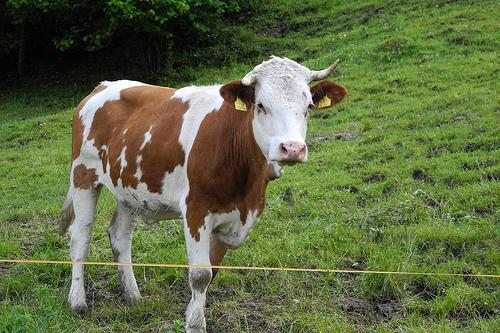What color is the tag on the cow's ear? Yellow. Analyze the cow's current action based on its positioning and surroundings. The cow is walking on grass with its feet visible and tail hanging down. Describe the surroundings of the cow. The cow is in a grassy area with green trees in the background and a shadow under a tree. What two colors make up the cow's fur? Brown and white. What type of vegetation are the cow and the tree growing from? Grassy hill and field. Tell me which part of the cow is pink. The cow's nose is pink. Enumerate the colors you can find in the grass. The grass is thick and green. Explain the image's quality according to the objects' details and level of clarity. The image has a high level of clarity and detail as the objects are clearly defined and contain specific coordinates and dimensions. Identify the object that's restricting the cow's movement. The yellow string or cord in front of the cow. How many legs does the cow have and what color are they? The cow has four legs and they are white. What is the color and shape of the cow's eyes and the state of its ears in the image? The cow has brown, dark eyes and brown, upright ears. Where does the tail of the cow appear to be hanging in the image? The tail of the cow is hanging down at the back. List the aspects of the cow's fur design that stand out in the image. The cow has brown and white fur patches, with some areas having tufts of white fur. Locate the orange cat sitting by the tree and describe its pose. There is no mention of any cats in the image. Requesting the user to locate a non-existent object and describe its pose is misleading. Notice the blue sky above the tree and measure its height. There is no mention of the sky in the image. Requesting the user to measure the height of a non-existent object in the image is misleading. What can you tell about the shadow under the tree in the image? There is a shadow under the tree, which suggests that the sunlight is creating contrast in the scene. Which of the following best describes the primary colors of the cow in the image? A) Brown and White B) Black and White C) Red and Blue A) Brown and White Identify the type and color of the tags in the cow's ear and the color of its horns. The cow has yellow tags in its ear and white horns. Describe the appearance of the surface under the cow in the image. The surface is covered with thick green grass. Identify any unique markings you can see on the cow's body in the image. A distinctive white patch can be seen on the cow's body. Analyze the interaction between the cow and the grass in the image. The cow walks on the thick green grass, with one foot partially hidden in the grass, indicating its engagement with the environment. Is the grassy hill located in the foreground or the background of the image? The grassy hill is located in the foreground of the image. Find the pink balloon floating above the cow's head. There is no mention of any balloons in the image. Requesting the user to look for a non-existent object is misleading.  Write a sentence that describes how the cow and the tree are connected by their environment in the image. The cow walks on the thick green grass while the green trees stand tall behind it, creating a harmonious picture of nature. Identify the position of the yellow string in relation to the cow in the image. The yellow string is in front of the cow. Examine the presence and location of trees in the image. There are green trees in the background. Which parts of the cow's body are white in the image? The cow has a white face, white horns, and white legs. Is the cow carrying a bag on its back? Identify the bag's color. The image does not contain any information about the cow carrying a bag. Asking the user to find a bag and identify its color is misleading. Do the cow's legs and tail have the same color pattern as the rest of its body? Yes, the cow's legs and tail have the same color pattern as the rest of its body. Describe the cow's facial features and their colors in the image. The cow has a white face, brown eyes, pink nose, and brown ears. Additionally, it has yellow tags in its ears and white horns. What kind of fruit is the cow eating from the ground? No fruits or eating behavior are mentioned in the image. Asking the user to recognize the fruit being eaten is misleading. What action does the cow appear to be performing in the image? The cow appears to be walking on the grass. Observe the group of chickens near the cow's legs. No chickens were mentioned in the image. Looking for a group of chickens is misleading as they don't exist within the given data. Is the cow standing on a grassy hill or a sandy beach? The cow is standing on a grassy hill. 